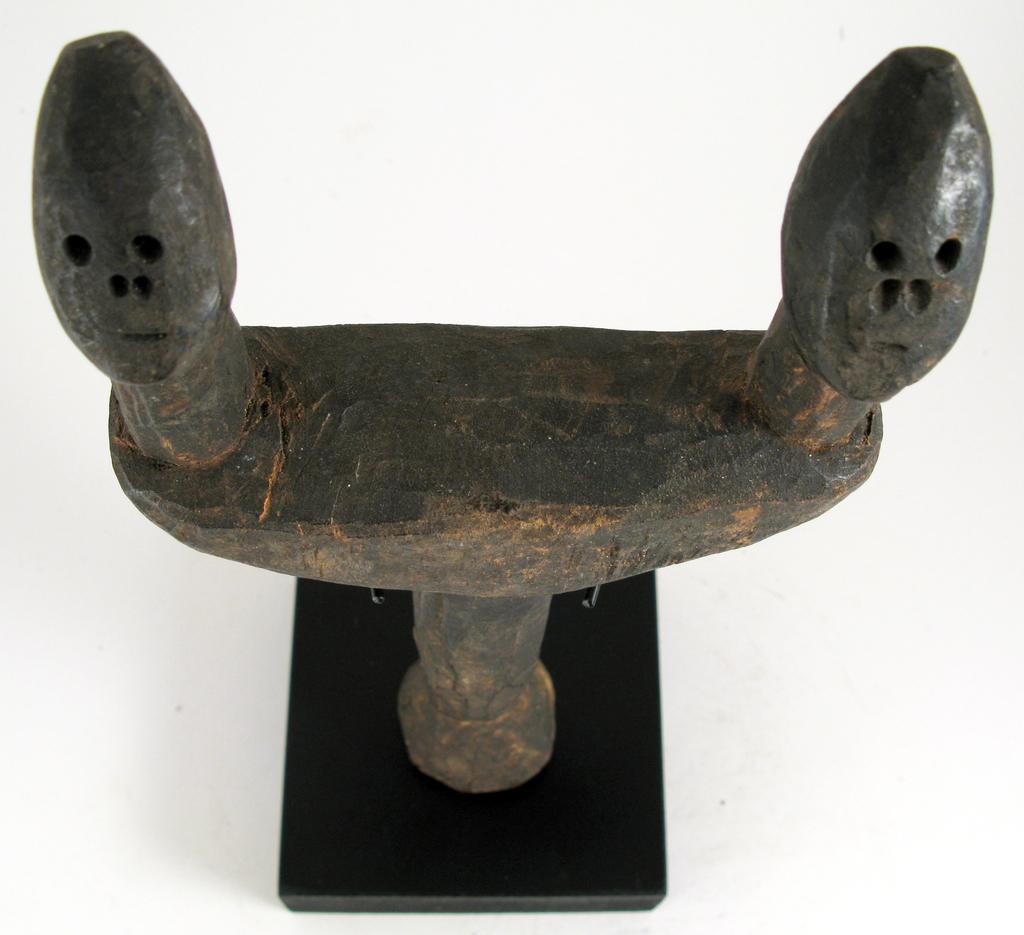What type of sculpture is in the image? There is a bronze sculpture in the image. What can be seen in the background of the image? The background of the image features a plane. What type of ray is being served at the feast in the image? There is no feast or ray present in the image. What hobbies does the person in the image have? There is no person present in the image, so their hobbies cannot be determined. 